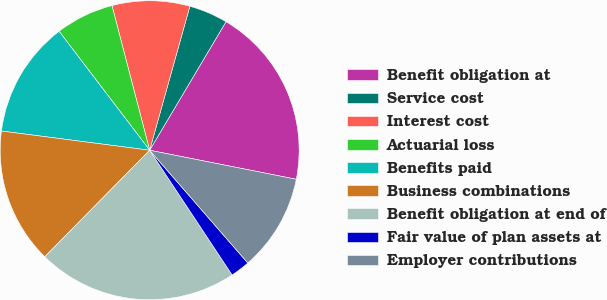Convert chart. <chart><loc_0><loc_0><loc_500><loc_500><pie_chart><fcel>Benefit obligation at<fcel>Service cost<fcel>Interest cost<fcel>Actuarial loss<fcel>Benefits paid<fcel>Business combinations<fcel>Benefit obligation at end of<fcel>Fair value of plan assets at<fcel>Employer contributions<nl><fcel>19.58%<fcel>4.2%<fcel>8.39%<fcel>6.3%<fcel>12.59%<fcel>14.68%<fcel>21.67%<fcel>2.1%<fcel>10.49%<nl></chart> 